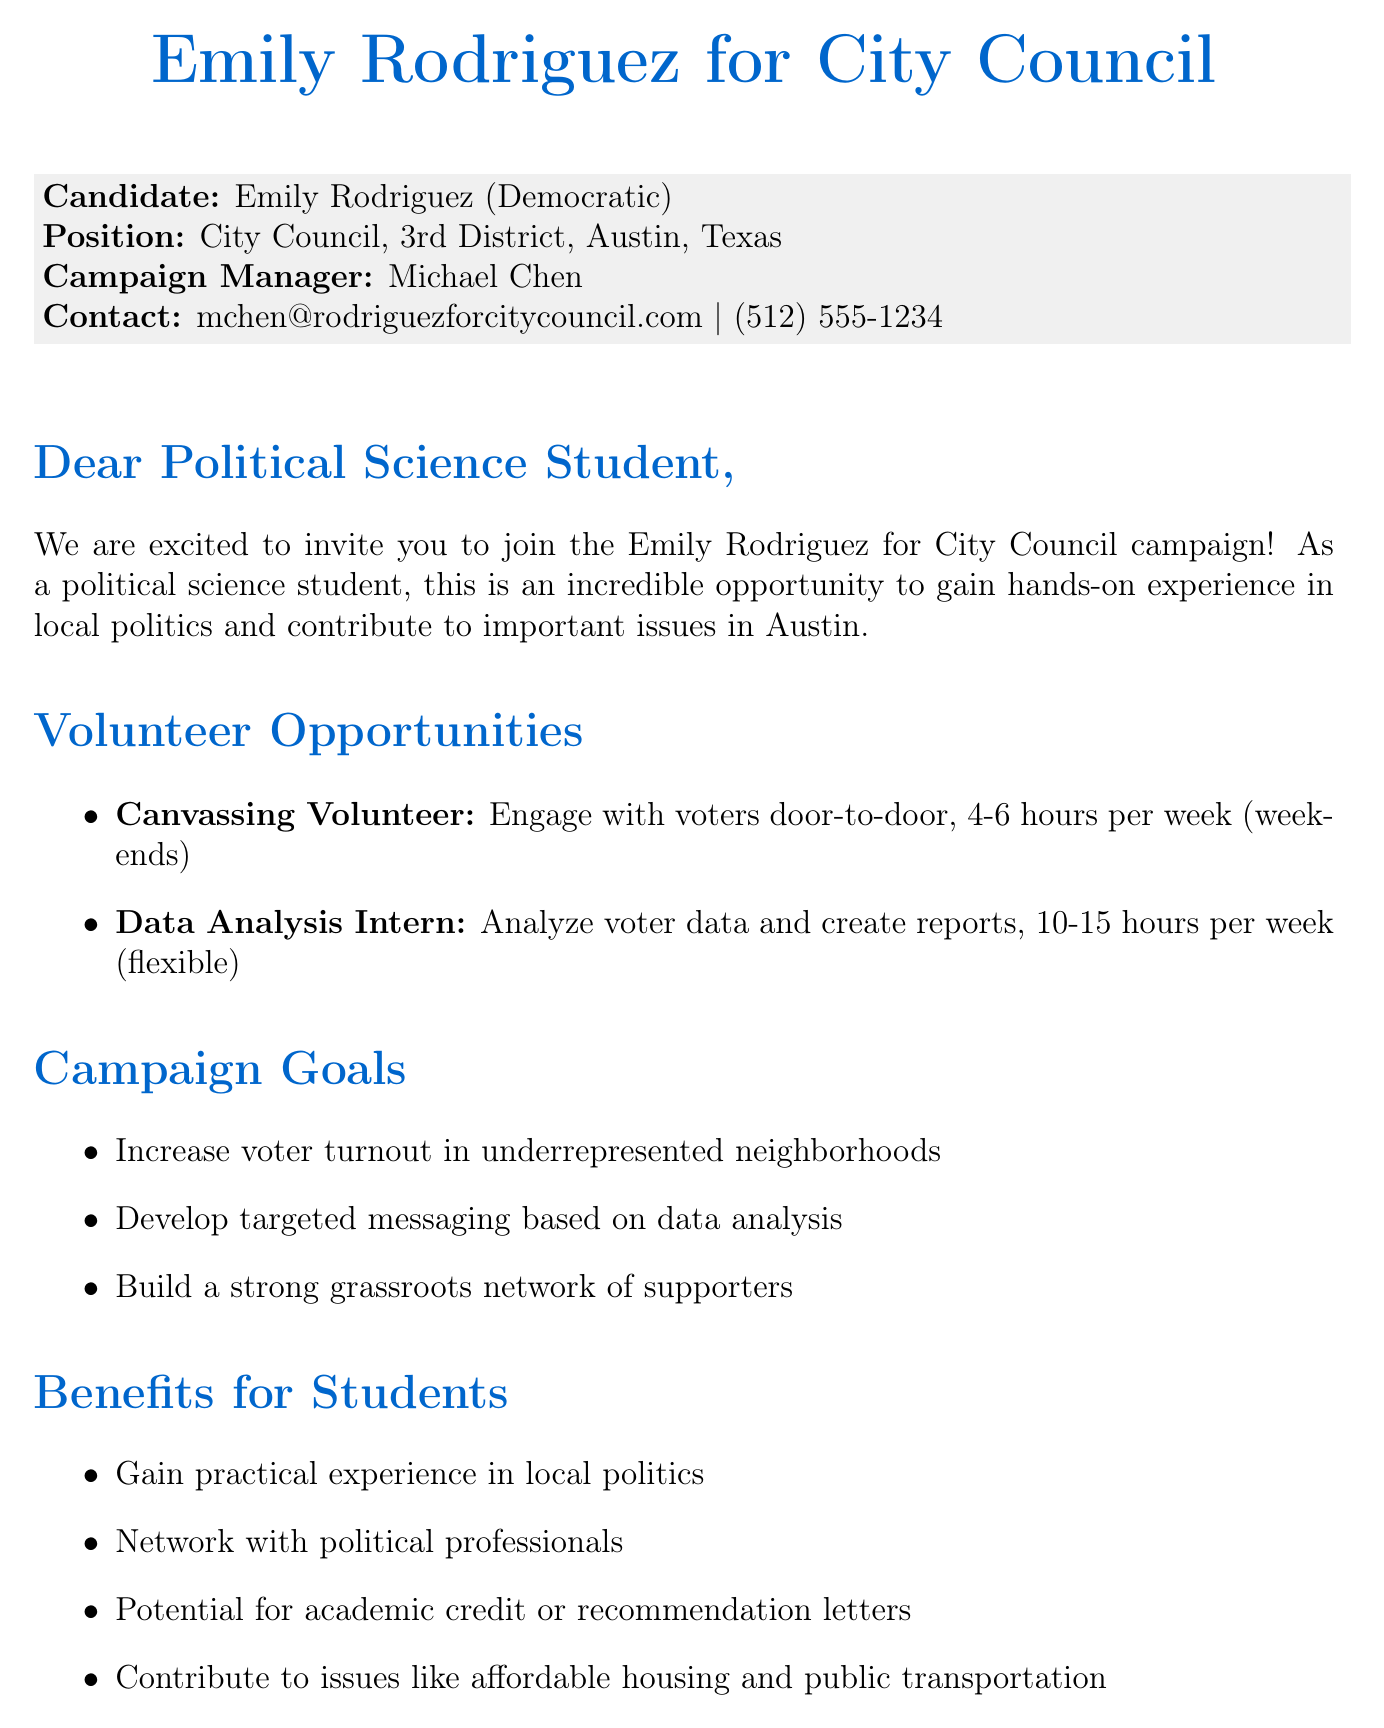What is the name of the candidate? The candidate's name is mentioned at the beginning of the document as Emily Rodriguez.
Answer: Emily Rodriguez What is the political affiliation of Emily Rodriguez? The document states her party affiliation as Democratic.
Answer: Democratic When is the volunteer application deadline? The deadline for applications is clearly stated in the document.
Answer: September 10, 2023 What is the contact email for the campaign manager? The document provides the email contact for the campaign manager, Michael Chen.
Answer: mchen@rodriguezforcitycouncil.com How many hours per week is a canvassing volunteer expected to commit? The time commitment for the canvassing volunteer role is specified in the document.
Answer: 4-6 hours What skills are required for the Data Analysis Intern position? The document lists the skills required for the data analysis role.
Answer: Statistical analysis, Proficiency in Excel or R, Attention to detail What event is scheduled for September 22, 2023? The document mentions an upcoming event on this date.
Answer: Data Analysis Workshop What is one of the campaign goals? The document outlines the goals of the campaign, providing specific objectives.
Answer: Increase voter turnout in traditionally underrepresented neighborhoods Which organizations are involved with the campaign? The document lists organizations associated with the campaign.
Answer: University Democrats, Austin Young Democrats, UT Austin Political Science Students Association 